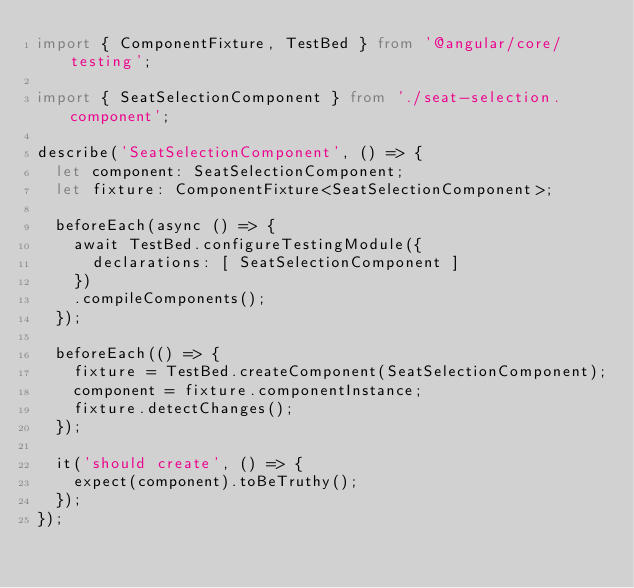<code> <loc_0><loc_0><loc_500><loc_500><_TypeScript_>import { ComponentFixture, TestBed } from '@angular/core/testing';

import { SeatSelectionComponent } from './seat-selection.component';

describe('SeatSelectionComponent', () => {
  let component: SeatSelectionComponent;
  let fixture: ComponentFixture<SeatSelectionComponent>;

  beforeEach(async () => {
    await TestBed.configureTestingModule({
      declarations: [ SeatSelectionComponent ]
    })
    .compileComponents();
  });

  beforeEach(() => {
    fixture = TestBed.createComponent(SeatSelectionComponent);
    component = fixture.componentInstance;
    fixture.detectChanges();
  });

  it('should create', () => {
    expect(component).toBeTruthy();
  });
});
</code> 